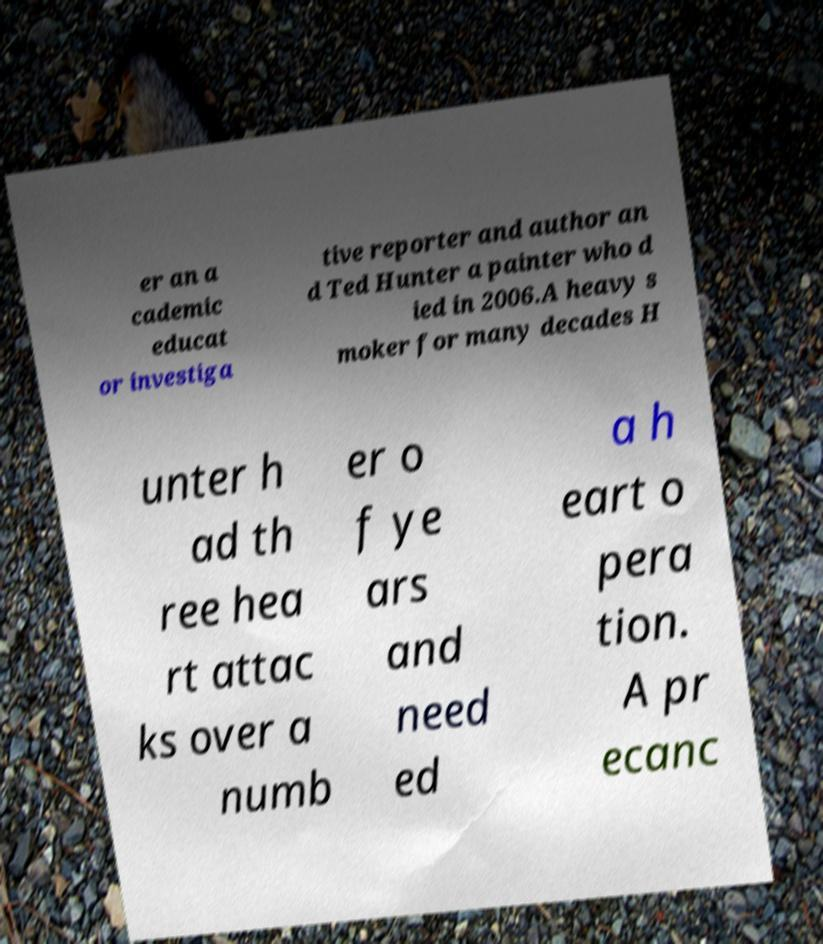I need the written content from this picture converted into text. Can you do that? er an a cademic educat or investiga tive reporter and author an d Ted Hunter a painter who d ied in 2006.A heavy s moker for many decades H unter h ad th ree hea rt attac ks over a numb er o f ye ars and need ed a h eart o pera tion. A pr ecanc 